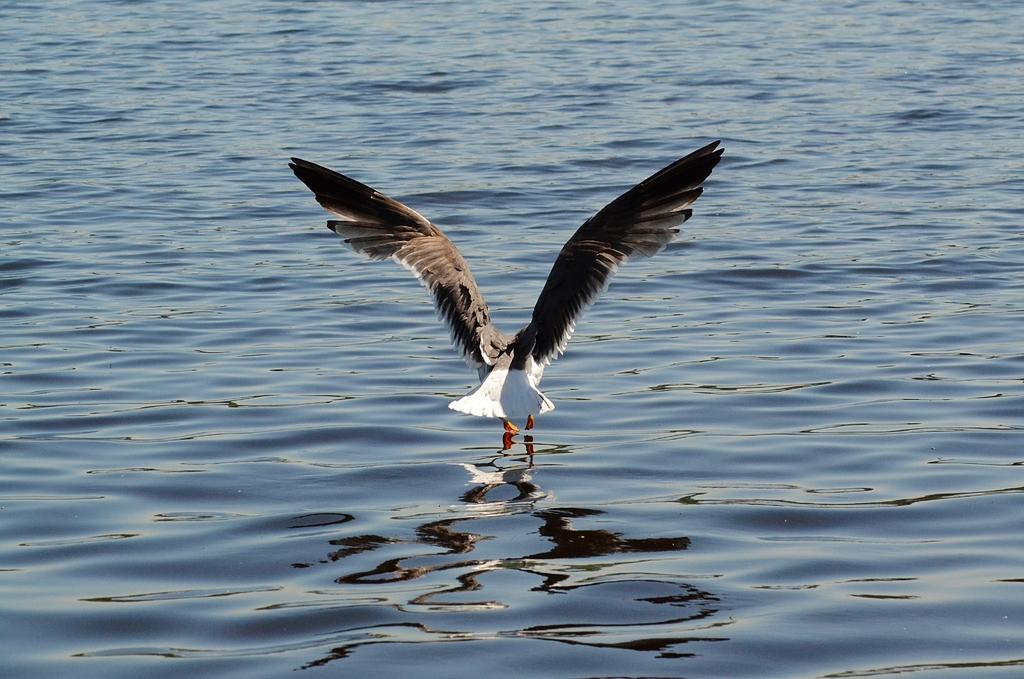What type of animal can be seen in the picture? There is a bird in the picture. What colors are present on the bird? The bird is white and black in color. What is the bird doing in the image? The bird is flying. What natural element is visible in the image? There is water visible in the image. What type of card is being used by the army in the image? There is no army or card present in the image; it features a bird flying over water. 